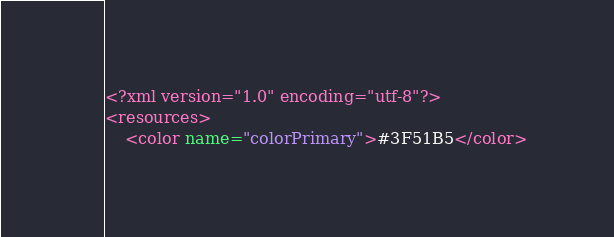<code> <loc_0><loc_0><loc_500><loc_500><_XML_><?xml version="1.0" encoding="utf-8"?>
<resources>
    <color name="colorPrimary">#3F51B5</color></code> 